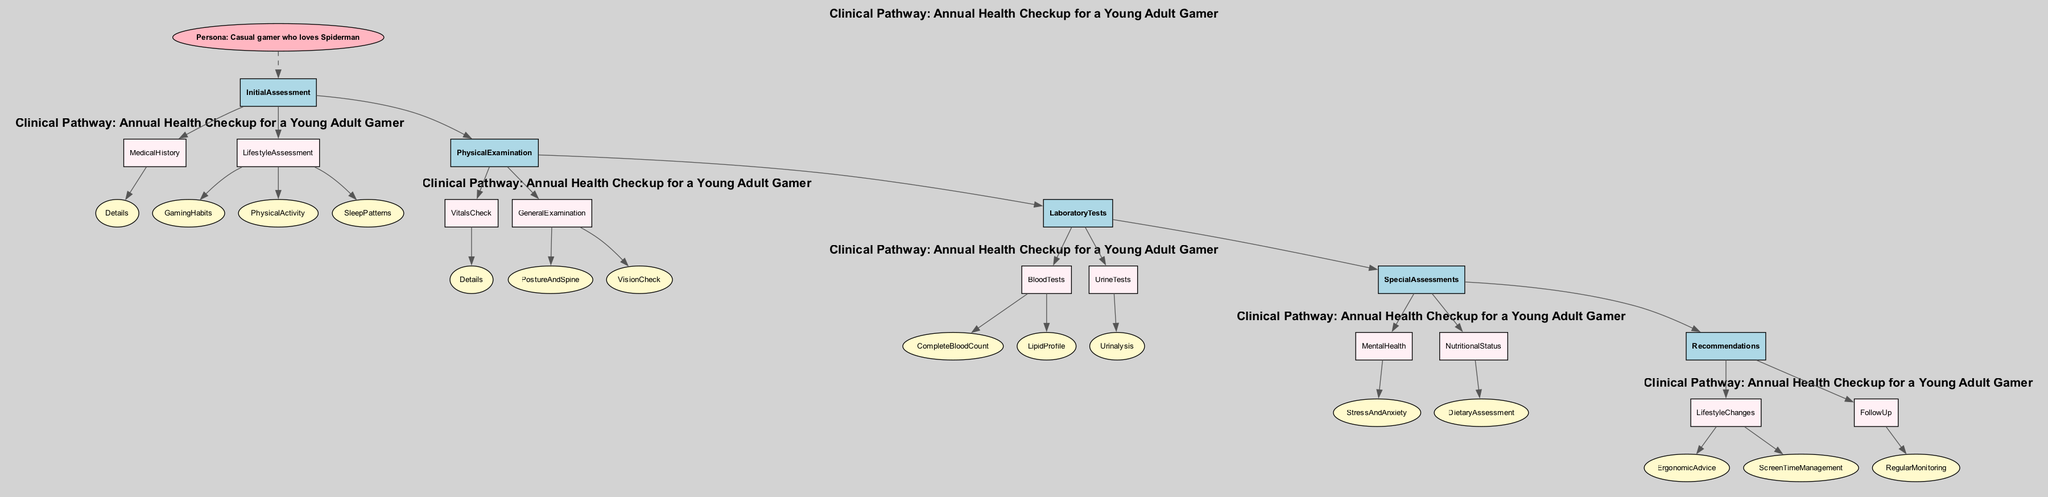What is the main topic of the clinical pathway? The diagram states that the main topic is "Annual Health Checkup for a Young Adult Gamer," which is explicitly mentioned in the introduction section.
Answer: Annual Health Checkup for a Young Adult Gamer How many main assessment categories are included? The diagram shows five main categories: Initial Assessment, Physical Examination, Laboratory Tests, Special Assessments, and Recommendations. Counting these categories confirms there are five.
Answer: 5 What type of assessment evaluates screen time habits? The Lifestyle Assessment section of the Initial Assessment specifically mentions "GamingHabits," which refers to screen time habits related to gaming.
Answer: GamingHabits What specific check is done for vision issues? The General Examination section includes "VisionCheck," which clearly indicates that an eye examination is conducted to check for vision problems.
Answer: VisionCheck Which laboratory test assesses cholesterol levels? In the Laboratory Tests section, “LipidProfile” is listed under Blood Tests, which checks cholesterol levels as part of evaluating cardiovascular health.
Answer: LipidProfile What recommendation is provided for managing screen time? The Recommendations section includes "ScreenTimeManagement," offering tips to manage screen time effectively and suggests incorporating regular breaks.
Answer: ScreenTimeManagement Which specific node relates to nutritional advice? In the Special Assessments category, the node titled “NutritionalStatus” contains a "DietaryAssessment" which analyzes dietary habits and provides recommendations as needed.
Answer: DietaryAssessment How do mental health evaluations fit into the clinical pathway? The Mental Health assessment under Special Assessments focuses on "StressAndAnxiety," indicating that mental health evaluations are an integral part of the pathway to identify any issues related to stress and gaming addiction.
Answer: StressAndAnxiety What is the relationship between the persona and the Initial Assessment? The diagram shows a dashed line connecting the "Persona" node to the "InitialAssessment" node, indicating that the persona influences the initial assessment decisions made during the pathway.
Answer: Dashed line connection 